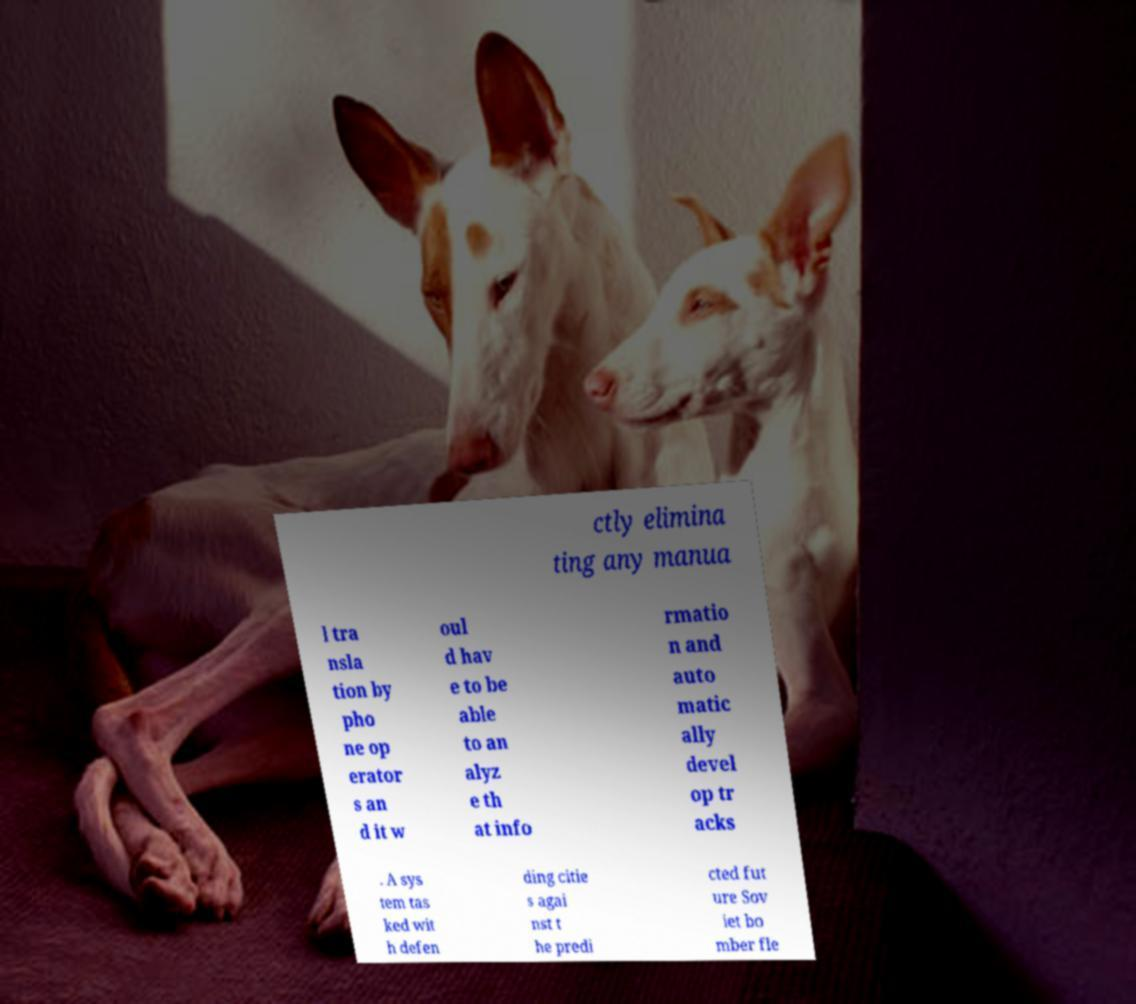What messages or text are displayed in this image? I need them in a readable, typed format. ctly elimina ting any manua l tra nsla tion by pho ne op erator s an d it w oul d hav e to be able to an alyz e th at info rmatio n and auto matic ally devel op tr acks . A sys tem tas ked wit h defen ding citie s agai nst t he predi cted fut ure Sov iet bo mber fle 